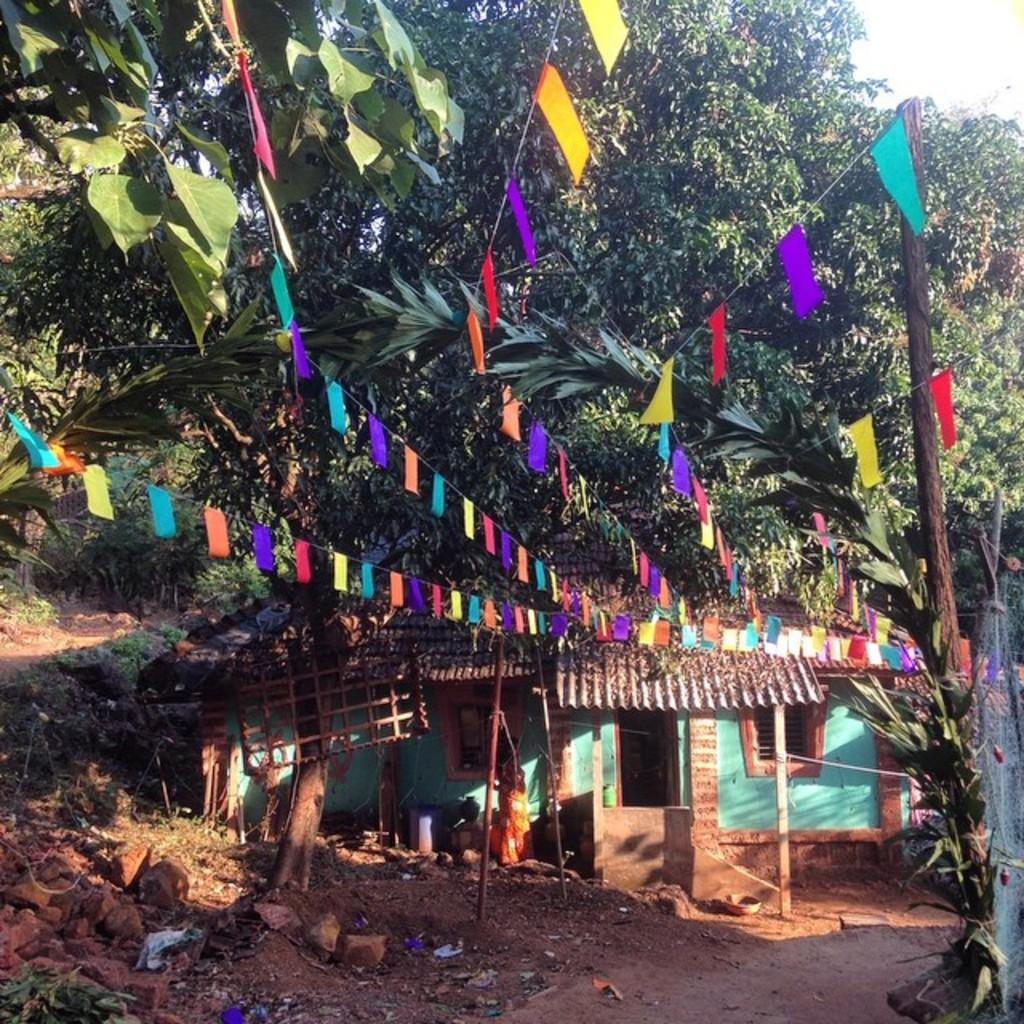What type of land is visible in the image? There is a land in the image, but no specific details are provided about its type. What structures can be seen in the background of the image? There is a house and trees in the background of the image. What are the flags in the image used for? The purpose of the flags in the image is not specified. What type of quilt is being used to cover the country in the image? There is no quilt or country present in the image. How does the show in the image depict the land? There is no show present in the image. 